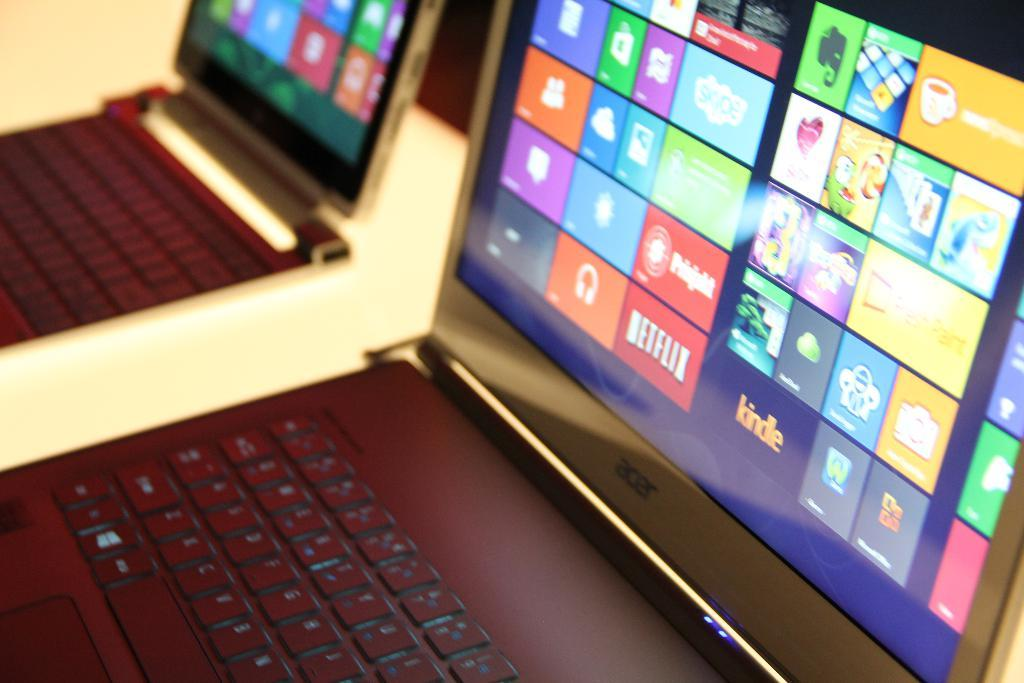<image>
Write a terse but informative summary of the picture. Netflix is shown in red on the icons shown on the screen. 